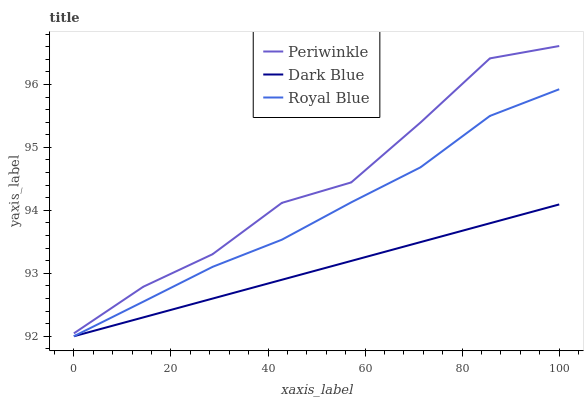Does Royal Blue have the minimum area under the curve?
Answer yes or no. No. Does Royal Blue have the maximum area under the curve?
Answer yes or no. No. Is Royal Blue the smoothest?
Answer yes or no. No. Is Royal Blue the roughest?
Answer yes or no. No. Does Periwinkle have the lowest value?
Answer yes or no. No. Does Royal Blue have the highest value?
Answer yes or no. No. Is Dark Blue less than Periwinkle?
Answer yes or no. Yes. Is Periwinkle greater than Dark Blue?
Answer yes or no. Yes. Does Dark Blue intersect Periwinkle?
Answer yes or no. No. 